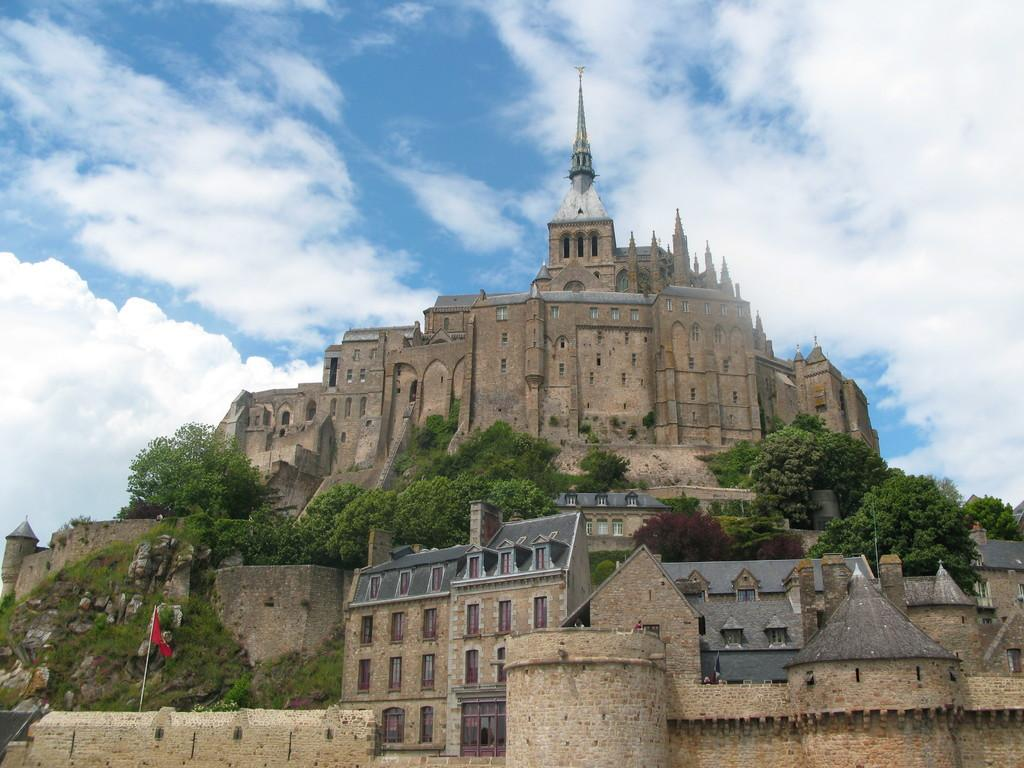What type of structure is located on the hill in the image? There is a castle on a hill in the image. What can be seen on the hill besides the castle? There are trees and plants on the hill. Where is the flag located in the image? The flag is on the wall in the bottom left of the image. What is visible at the top of the image? The sky is visible at the top of the image. What is the price of the desk in the image? There is no desk present in the image, so it is not possible to determine its price. 